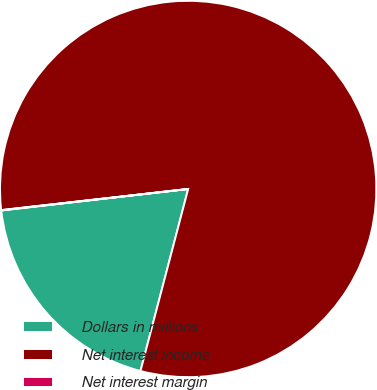<chart> <loc_0><loc_0><loc_500><loc_500><pie_chart><fcel>Dollars in millions<fcel>Net interest income<fcel>Net interest margin<nl><fcel>19.1%<fcel>80.87%<fcel>0.03%<nl></chart> 